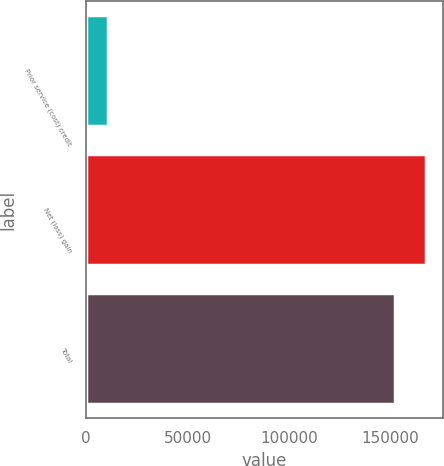Convert chart. <chart><loc_0><loc_0><loc_500><loc_500><bar_chart><fcel>Prior service (cost) credit<fcel>Net (loss) gain<fcel>Total<nl><fcel>10619<fcel>167632<fcel>152393<nl></chart> 